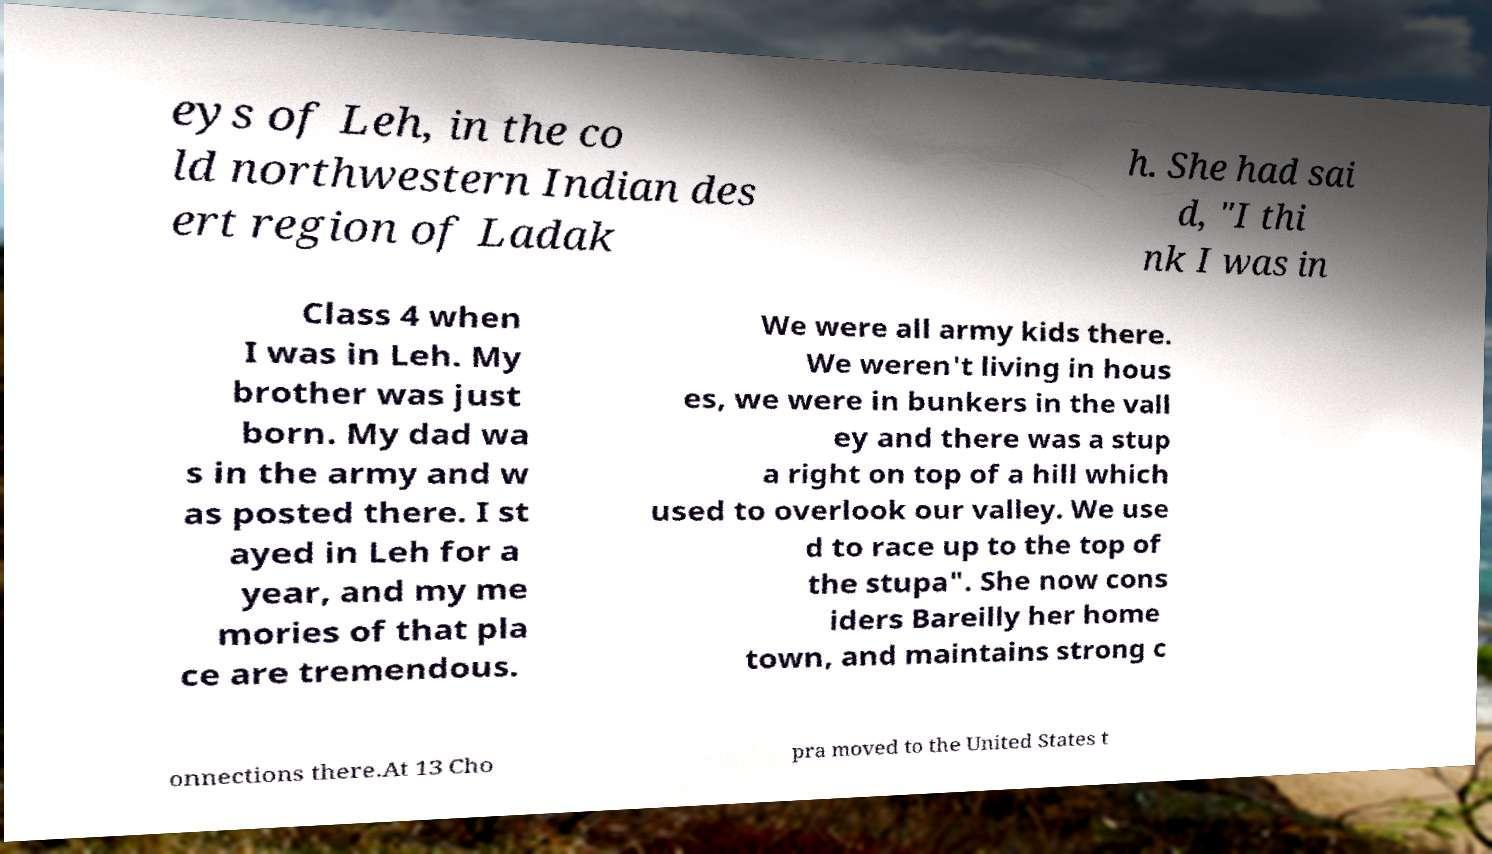Could you extract and type out the text from this image? eys of Leh, in the co ld northwestern Indian des ert region of Ladak h. She had sai d, "I thi nk I was in Class 4 when I was in Leh. My brother was just born. My dad wa s in the army and w as posted there. I st ayed in Leh for a year, and my me mories of that pla ce are tremendous. We were all army kids there. We weren't living in hous es, we were in bunkers in the vall ey and there was a stup a right on top of a hill which used to overlook our valley. We use d to race up to the top of the stupa". She now cons iders Bareilly her home town, and maintains strong c onnections there.At 13 Cho pra moved to the United States t 